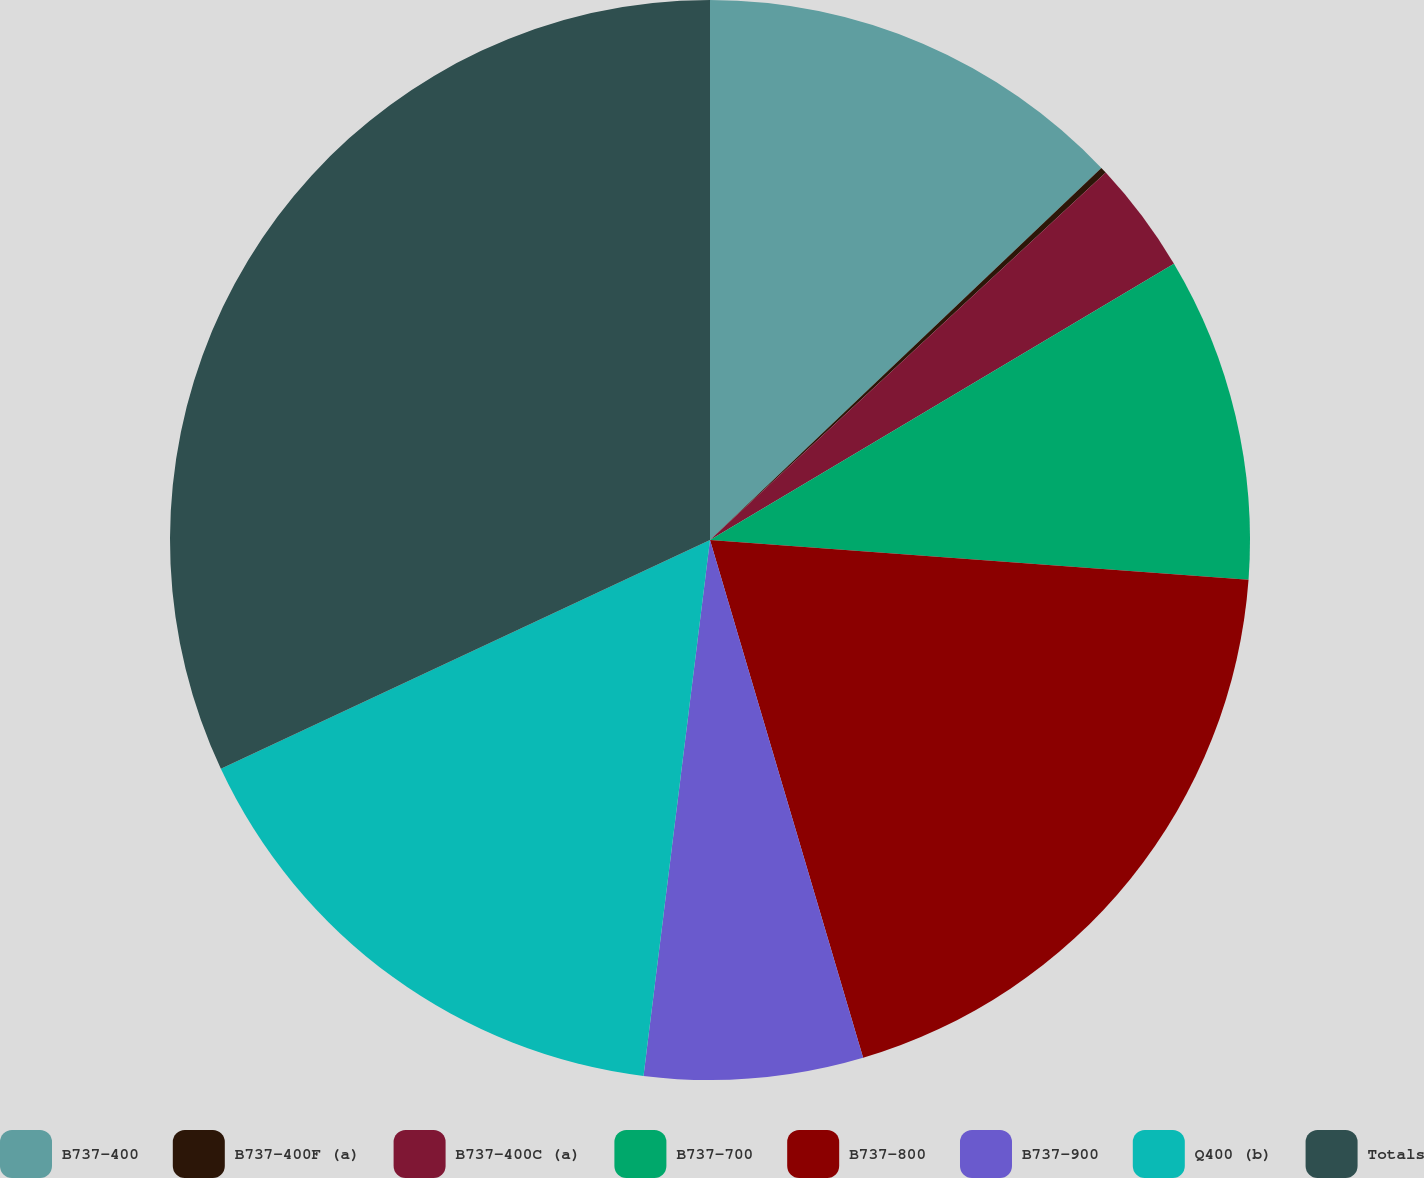Convert chart to OTSL. <chart><loc_0><loc_0><loc_500><loc_500><pie_chart><fcel>B737-400<fcel>B737-400F (a)<fcel>B737-400C (a)<fcel>B737-700<fcel>B737-800<fcel>B737-900<fcel>Q400 (b)<fcel>Totals<nl><fcel>12.9%<fcel>0.19%<fcel>3.36%<fcel>9.72%<fcel>19.25%<fcel>6.54%<fcel>16.07%<fcel>31.96%<nl></chart> 